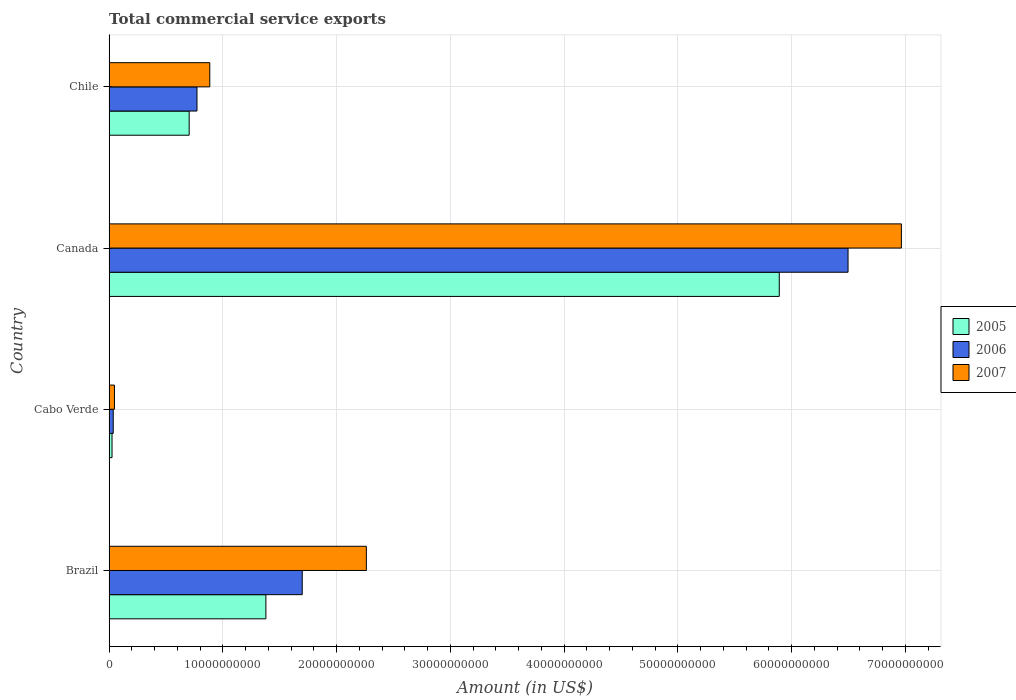How many different coloured bars are there?
Offer a terse response. 3. Are the number of bars per tick equal to the number of legend labels?
Provide a succinct answer. Yes. Are the number of bars on each tick of the Y-axis equal?
Offer a terse response. Yes. How many bars are there on the 1st tick from the bottom?
Make the answer very short. 3. In how many cases, is the number of bars for a given country not equal to the number of legend labels?
Give a very brief answer. 0. What is the total commercial service exports in 2006 in Cabo Verde?
Your answer should be compact. 3.66e+08. Across all countries, what is the maximum total commercial service exports in 2007?
Offer a very short reply. 6.96e+1. Across all countries, what is the minimum total commercial service exports in 2007?
Offer a terse response. 4.74e+08. In which country was the total commercial service exports in 2007 minimum?
Ensure brevity in your answer.  Cabo Verde. What is the total total commercial service exports in 2006 in the graph?
Your answer should be compact. 9.00e+1. What is the difference between the total commercial service exports in 2005 in Brazil and that in Chile?
Ensure brevity in your answer.  6.74e+09. What is the difference between the total commercial service exports in 2006 in Canada and the total commercial service exports in 2005 in Cabo Verde?
Your response must be concise. 6.47e+1. What is the average total commercial service exports in 2006 per country?
Offer a terse response. 2.25e+1. What is the difference between the total commercial service exports in 2005 and total commercial service exports in 2006 in Brazil?
Make the answer very short. -3.19e+09. In how many countries, is the total commercial service exports in 2006 greater than 58000000000 US$?
Provide a short and direct response. 1. What is the ratio of the total commercial service exports in 2005 in Cabo Verde to that in Chile?
Offer a terse response. 0.04. What is the difference between the highest and the second highest total commercial service exports in 2007?
Ensure brevity in your answer.  4.70e+1. What is the difference between the highest and the lowest total commercial service exports in 2006?
Your answer should be compact. 6.46e+1. Is the sum of the total commercial service exports in 2005 in Cabo Verde and Canada greater than the maximum total commercial service exports in 2006 across all countries?
Provide a short and direct response. No. What does the 1st bar from the bottom in Cabo Verde represents?
Offer a very short reply. 2005. Does the graph contain any zero values?
Provide a succinct answer. No. Does the graph contain grids?
Your response must be concise. Yes. How many legend labels are there?
Ensure brevity in your answer.  3. How are the legend labels stacked?
Provide a short and direct response. Vertical. What is the title of the graph?
Ensure brevity in your answer.  Total commercial service exports. Does "2003" appear as one of the legend labels in the graph?
Provide a short and direct response. No. What is the label or title of the X-axis?
Give a very brief answer. Amount (in US$). What is the Amount (in US$) of 2005 in Brazil?
Your response must be concise. 1.38e+1. What is the Amount (in US$) in 2006 in Brazil?
Your answer should be very brief. 1.70e+1. What is the Amount (in US$) of 2007 in Brazil?
Provide a succinct answer. 2.26e+1. What is the Amount (in US$) in 2005 in Cabo Verde?
Make the answer very short. 2.60e+08. What is the Amount (in US$) in 2006 in Cabo Verde?
Your response must be concise. 3.66e+08. What is the Amount (in US$) of 2007 in Cabo Verde?
Your answer should be compact. 4.74e+08. What is the Amount (in US$) of 2005 in Canada?
Keep it short and to the point. 5.89e+1. What is the Amount (in US$) in 2006 in Canada?
Offer a very short reply. 6.50e+1. What is the Amount (in US$) of 2007 in Canada?
Provide a short and direct response. 6.96e+1. What is the Amount (in US$) in 2005 in Chile?
Give a very brief answer. 7.04e+09. What is the Amount (in US$) of 2006 in Chile?
Offer a terse response. 7.73e+09. What is the Amount (in US$) in 2007 in Chile?
Make the answer very short. 8.85e+09. Across all countries, what is the maximum Amount (in US$) of 2005?
Make the answer very short. 5.89e+1. Across all countries, what is the maximum Amount (in US$) in 2006?
Provide a succinct answer. 6.50e+1. Across all countries, what is the maximum Amount (in US$) of 2007?
Offer a very short reply. 6.96e+1. Across all countries, what is the minimum Amount (in US$) of 2005?
Offer a terse response. 2.60e+08. Across all countries, what is the minimum Amount (in US$) of 2006?
Give a very brief answer. 3.66e+08. Across all countries, what is the minimum Amount (in US$) in 2007?
Keep it short and to the point. 4.74e+08. What is the total Amount (in US$) in 2005 in the graph?
Keep it short and to the point. 8.00e+1. What is the total Amount (in US$) of 2006 in the graph?
Provide a short and direct response. 9.00e+1. What is the total Amount (in US$) in 2007 in the graph?
Provide a succinct answer. 1.02e+11. What is the difference between the Amount (in US$) of 2005 in Brazil and that in Cabo Verde?
Keep it short and to the point. 1.35e+1. What is the difference between the Amount (in US$) in 2006 in Brazil and that in Cabo Verde?
Your answer should be compact. 1.66e+1. What is the difference between the Amount (in US$) of 2007 in Brazil and that in Cabo Verde?
Your answer should be compact. 2.21e+1. What is the difference between the Amount (in US$) of 2005 in Brazil and that in Canada?
Your answer should be very brief. -4.51e+1. What is the difference between the Amount (in US$) in 2006 in Brazil and that in Canada?
Provide a short and direct response. -4.80e+1. What is the difference between the Amount (in US$) of 2007 in Brazil and that in Canada?
Your answer should be very brief. -4.70e+1. What is the difference between the Amount (in US$) in 2005 in Brazil and that in Chile?
Offer a terse response. 6.74e+09. What is the difference between the Amount (in US$) in 2006 in Brazil and that in Chile?
Your answer should be very brief. 9.25e+09. What is the difference between the Amount (in US$) in 2007 in Brazil and that in Chile?
Your response must be concise. 1.38e+1. What is the difference between the Amount (in US$) in 2005 in Cabo Verde and that in Canada?
Provide a short and direct response. -5.86e+1. What is the difference between the Amount (in US$) in 2006 in Cabo Verde and that in Canada?
Provide a succinct answer. -6.46e+1. What is the difference between the Amount (in US$) in 2007 in Cabo Verde and that in Canada?
Make the answer very short. -6.92e+1. What is the difference between the Amount (in US$) in 2005 in Cabo Verde and that in Chile?
Offer a very short reply. -6.78e+09. What is the difference between the Amount (in US$) of 2006 in Cabo Verde and that in Chile?
Keep it short and to the point. -7.36e+09. What is the difference between the Amount (in US$) of 2007 in Cabo Verde and that in Chile?
Provide a succinct answer. -8.38e+09. What is the difference between the Amount (in US$) of 2005 in Canada and that in Chile?
Your response must be concise. 5.19e+1. What is the difference between the Amount (in US$) of 2006 in Canada and that in Chile?
Ensure brevity in your answer.  5.72e+1. What is the difference between the Amount (in US$) in 2007 in Canada and that in Chile?
Your answer should be very brief. 6.08e+1. What is the difference between the Amount (in US$) in 2005 in Brazil and the Amount (in US$) in 2006 in Cabo Verde?
Your answer should be compact. 1.34e+1. What is the difference between the Amount (in US$) in 2005 in Brazil and the Amount (in US$) in 2007 in Cabo Verde?
Make the answer very short. 1.33e+1. What is the difference between the Amount (in US$) of 2006 in Brazil and the Amount (in US$) of 2007 in Cabo Verde?
Ensure brevity in your answer.  1.65e+1. What is the difference between the Amount (in US$) of 2005 in Brazil and the Amount (in US$) of 2006 in Canada?
Give a very brief answer. -5.12e+1. What is the difference between the Amount (in US$) in 2005 in Brazil and the Amount (in US$) in 2007 in Canada?
Offer a terse response. -5.59e+1. What is the difference between the Amount (in US$) in 2006 in Brazil and the Amount (in US$) in 2007 in Canada?
Make the answer very short. -5.27e+1. What is the difference between the Amount (in US$) of 2005 in Brazil and the Amount (in US$) of 2006 in Chile?
Offer a terse response. 6.06e+09. What is the difference between the Amount (in US$) in 2005 in Brazil and the Amount (in US$) in 2007 in Chile?
Your answer should be compact. 4.93e+09. What is the difference between the Amount (in US$) in 2006 in Brazil and the Amount (in US$) in 2007 in Chile?
Make the answer very short. 8.13e+09. What is the difference between the Amount (in US$) of 2005 in Cabo Verde and the Amount (in US$) of 2006 in Canada?
Keep it short and to the point. -6.47e+1. What is the difference between the Amount (in US$) in 2005 in Cabo Verde and the Amount (in US$) in 2007 in Canada?
Your answer should be very brief. -6.94e+1. What is the difference between the Amount (in US$) of 2006 in Cabo Verde and the Amount (in US$) of 2007 in Canada?
Provide a succinct answer. -6.93e+1. What is the difference between the Amount (in US$) in 2005 in Cabo Verde and the Amount (in US$) in 2006 in Chile?
Keep it short and to the point. -7.47e+09. What is the difference between the Amount (in US$) of 2005 in Cabo Verde and the Amount (in US$) of 2007 in Chile?
Your answer should be very brief. -8.59e+09. What is the difference between the Amount (in US$) of 2006 in Cabo Verde and the Amount (in US$) of 2007 in Chile?
Provide a short and direct response. -8.49e+09. What is the difference between the Amount (in US$) in 2005 in Canada and the Amount (in US$) in 2006 in Chile?
Provide a short and direct response. 5.12e+1. What is the difference between the Amount (in US$) in 2005 in Canada and the Amount (in US$) in 2007 in Chile?
Offer a very short reply. 5.01e+1. What is the difference between the Amount (in US$) in 2006 in Canada and the Amount (in US$) in 2007 in Chile?
Offer a terse response. 5.61e+1. What is the average Amount (in US$) of 2005 per country?
Provide a succinct answer. 2.00e+1. What is the average Amount (in US$) of 2006 per country?
Provide a short and direct response. 2.25e+1. What is the average Amount (in US$) in 2007 per country?
Your answer should be compact. 2.54e+1. What is the difference between the Amount (in US$) in 2005 and Amount (in US$) in 2006 in Brazil?
Your answer should be compact. -3.19e+09. What is the difference between the Amount (in US$) of 2005 and Amount (in US$) of 2007 in Brazil?
Your answer should be very brief. -8.83e+09. What is the difference between the Amount (in US$) of 2006 and Amount (in US$) of 2007 in Brazil?
Make the answer very short. -5.64e+09. What is the difference between the Amount (in US$) in 2005 and Amount (in US$) in 2006 in Cabo Verde?
Your answer should be compact. -1.05e+08. What is the difference between the Amount (in US$) of 2005 and Amount (in US$) of 2007 in Cabo Verde?
Give a very brief answer. -2.13e+08. What is the difference between the Amount (in US$) of 2006 and Amount (in US$) of 2007 in Cabo Verde?
Provide a short and direct response. -1.08e+08. What is the difference between the Amount (in US$) of 2005 and Amount (in US$) of 2006 in Canada?
Your answer should be compact. -6.05e+09. What is the difference between the Amount (in US$) of 2005 and Amount (in US$) of 2007 in Canada?
Your answer should be very brief. -1.07e+1. What is the difference between the Amount (in US$) in 2006 and Amount (in US$) in 2007 in Canada?
Provide a short and direct response. -4.69e+09. What is the difference between the Amount (in US$) of 2005 and Amount (in US$) of 2006 in Chile?
Ensure brevity in your answer.  -6.87e+08. What is the difference between the Amount (in US$) of 2005 and Amount (in US$) of 2007 in Chile?
Your answer should be compact. -1.81e+09. What is the difference between the Amount (in US$) of 2006 and Amount (in US$) of 2007 in Chile?
Provide a succinct answer. -1.12e+09. What is the ratio of the Amount (in US$) of 2005 in Brazil to that in Cabo Verde?
Your answer should be very brief. 52.92. What is the ratio of the Amount (in US$) in 2006 in Brazil to that in Cabo Verde?
Give a very brief answer. 46.44. What is the ratio of the Amount (in US$) in 2007 in Brazil to that in Cabo Verde?
Your answer should be very brief. 47.74. What is the ratio of the Amount (in US$) in 2005 in Brazil to that in Canada?
Provide a short and direct response. 0.23. What is the ratio of the Amount (in US$) of 2006 in Brazil to that in Canada?
Your answer should be very brief. 0.26. What is the ratio of the Amount (in US$) in 2007 in Brazil to that in Canada?
Keep it short and to the point. 0.32. What is the ratio of the Amount (in US$) in 2005 in Brazil to that in Chile?
Provide a short and direct response. 1.96. What is the ratio of the Amount (in US$) of 2006 in Brazil to that in Chile?
Make the answer very short. 2.2. What is the ratio of the Amount (in US$) in 2007 in Brazil to that in Chile?
Offer a terse response. 2.55. What is the ratio of the Amount (in US$) in 2005 in Cabo Verde to that in Canada?
Your response must be concise. 0. What is the ratio of the Amount (in US$) in 2006 in Cabo Verde to that in Canada?
Your answer should be very brief. 0.01. What is the ratio of the Amount (in US$) of 2007 in Cabo Verde to that in Canada?
Make the answer very short. 0.01. What is the ratio of the Amount (in US$) of 2005 in Cabo Verde to that in Chile?
Provide a short and direct response. 0.04. What is the ratio of the Amount (in US$) of 2006 in Cabo Verde to that in Chile?
Offer a terse response. 0.05. What is the ratio of the Amount (in US$) of 2007 in Cabo Verde to that in Chile?
Your answer should be very brief. 0.05. What is the ratio of the Amount (in US$) of 2005 in Canada to that in Chile?
Provide a short and direct response. 8.37. What is the ratio of the Amount (in US$) in 2006 in Canada to that in Chile?
Give a very brief answer. 8.4. What is the ratio of the Amount (in US$) of 2007 in Canada to that in Chile?
Provide a succinct answer. 7.87. What is the difference between the highest and the second highest Amount (in US$) in 2005?
Your answer should be compact. 4.51e+1. What is the difference between the highest and the second highest Amount (in US$) in 2006?
Your answer should be compact. 4.80e+1. What is the difference between the highest and the second highest Amount (in US$) in 2007?
Provide a succinct answer. 4.70e+1. What is the difference between the highest and the lowest Amount (in US$) of 2005?
Your response must be concise. 5.86e+1. What is the difference between the highest and the lowest Amount (in US$) of 2006?
Offer a terse response. 6.46e+1. What is the difference between the highest and the lowest Amount (in US$) of 2007?
Your answer should be very brief. 6.92e+1. 